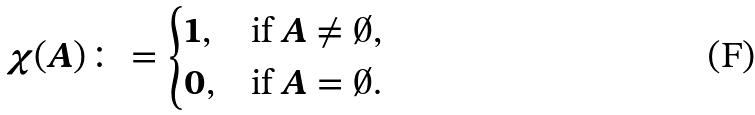<formula> <loc_0><loc_0><loc_500><loc_500>\chi ( A ) \colon = \begin{cases} 1 , & \text {if } A \neq \emptyset , \\ 0 , & \text {if } A = \emptyset . \end{cases}</formula> 